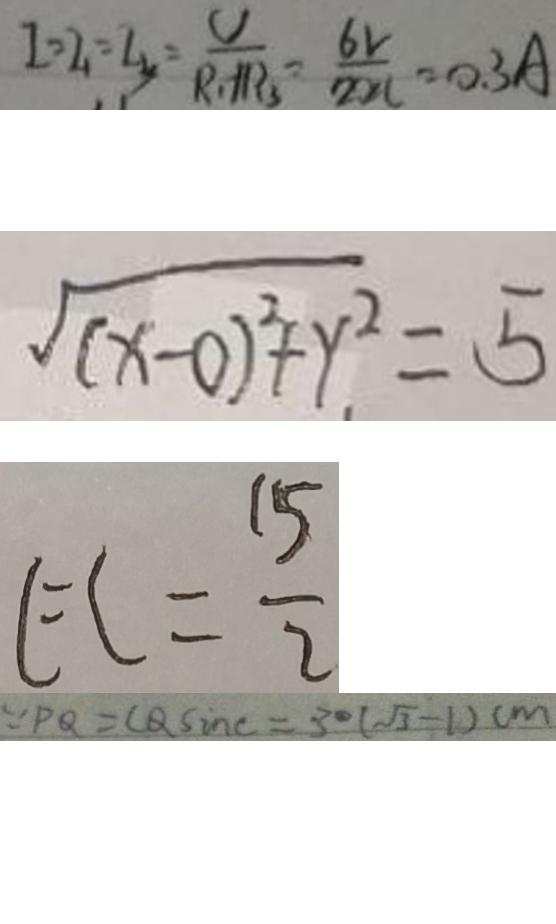<formula> <loc_0><loc_0><loc_500><loc_500>I = I _ { 1 } = I _ { 3 } = \frac { V } { R _ { 1 } + R _ { 3 } } = \frac { 6 V } { 2 0 \Omega } = 0 . 3 A 
 \sqrt { ( x - 0 ) ^ { 2 } + y . ^ { 2 } } = 5 
 E C = \frac { 1 5 } { 2 } 
 \because P Q = C Q \sin c = 3 0 ( \sqrt { 3 } - 1 ) c m</formula> 